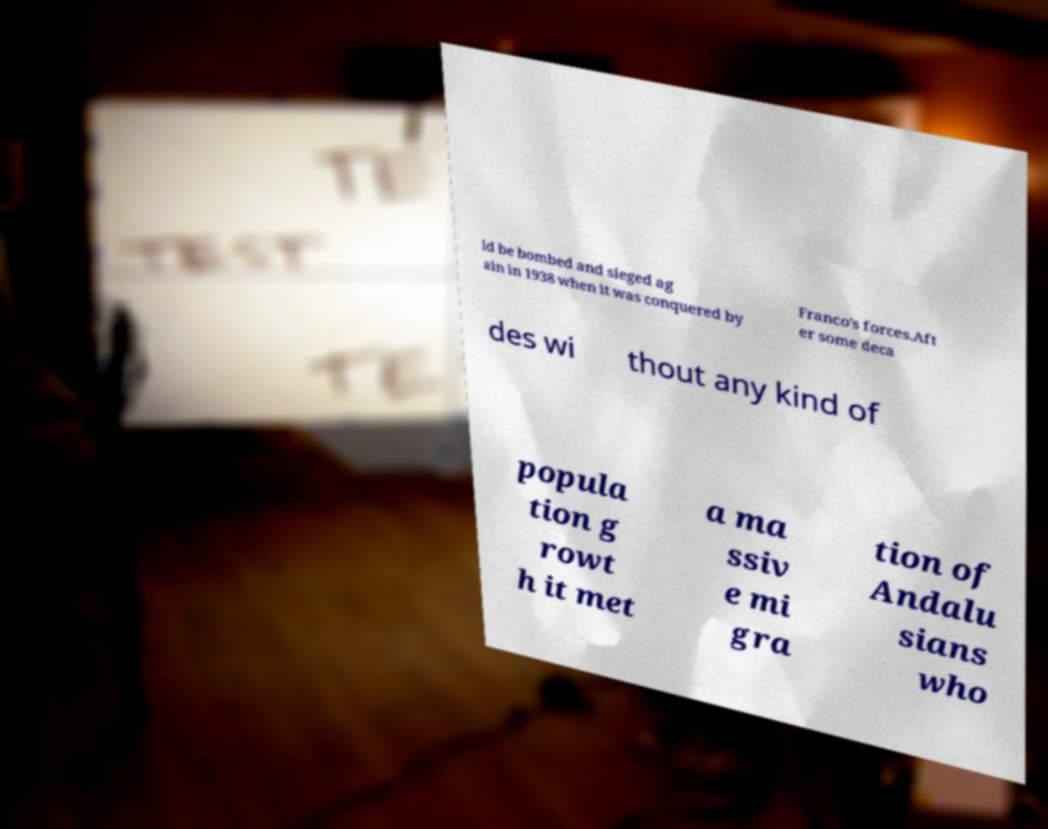There's text embedded in this image that I need extracted. Can you transcribe it verbatim? ld be bombed and sieged ag ain in 1938 when it was conquered by Franco's forces.Aft er some deca des wi thout any kind of popula tion g rowt h it met a ma ssiv e mi gra tion of Andalu sians who 